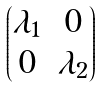Convert formula to latex. <formula><loc_0><loc_0><loc_500><loc_500>\begin{pmatrix} \lambda _ { 1 } & 0 \\ 0 & \lambda _ { 2 } \\ \end{pmatrix}</formula> 